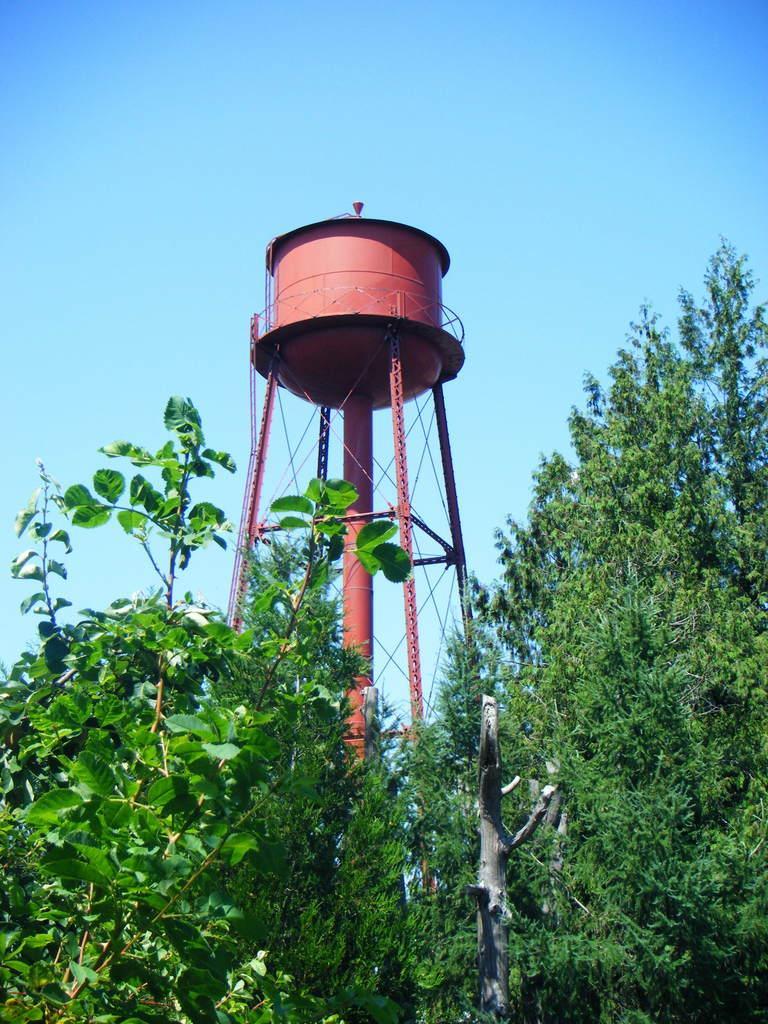How would you summarize this image in a sentence or two? In this image I can see few trees which are green in color, a tower which is brown in color and a water tank on it. In the background I can see the sky. 